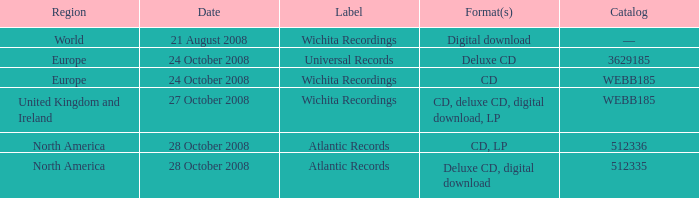Which catalog value has a region of world? —. 